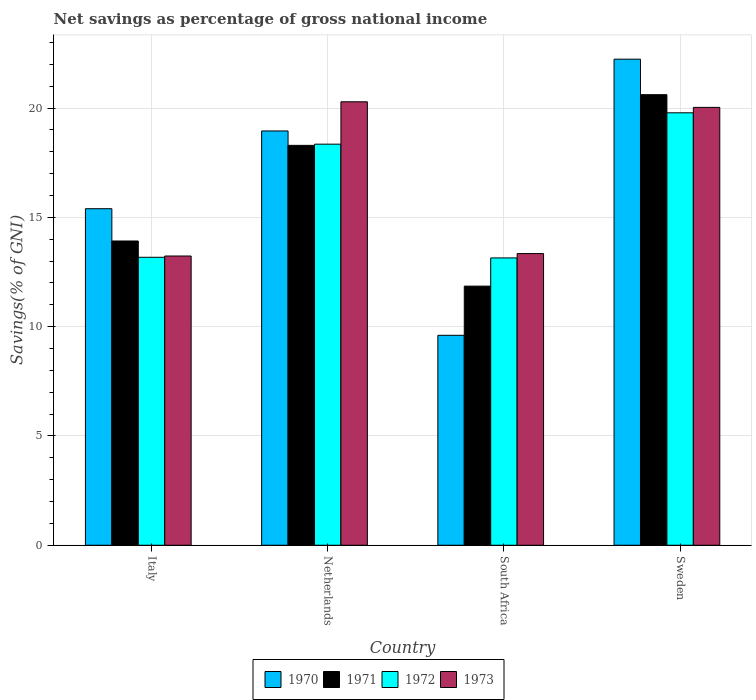How many different coloured bars are there?
Offer a very short reply. 4. How many groups of bars are there?
Your answer should be compact. 4. Are the number of bars on each tick of the X-axis equal?
Make the answer very short. Yes. How many bars are there on the 2nd tick from the left?
Offer a terse response. 4. How many bars are there on the 1st tick from the right?
Your answer should be very brief. 4. What is the label of the 4th group of bars from the left?
Your answer should be very brief. Sweden. What is the total savings in 1973 in South Africa?
Keep it short and to the point. 13.34. Across all countries, what is the maximum total savings in 1970?
Ensure brevity in your answer.  22.24. Across all countries, what is the minimum total savings in 1970?
Your response must be concise. 9.6. In which country was the total savings in 1972 minimum?
Your answer should be compact. South Africa. What is the total total savings in 1970 in the graph?
Keep it short and to the point. 66.19. What is the difference between the total savings in 1971 in Netherlands and that in Sweden?
Ensure brevity in your answer.  -2.32. What is the difference between the total savings in 1972 in South Africa and the total savings in 1973 in Sweden?
Provide a succinct answer. -6.89. What is the average total savings in 1971 per country?
Provide a short and direct response. 16.17. What is the difference between the total savings of/in 1970 and total savings of/in 1971 in South Africa?
Your response must be concise. -2.25. What is the ratio of the total savings in 1971 in Italy to that in Sweden?
Your response must be concise. 0.68. What is the difference between the highest and the second highest total savings in 1973?
Your answer should be very brief. -6.95. What is the difference between the highest and the lowest total savings in 1971?
Make the answer very short. 8.76. Is it the case that in every country, the sum of the total savings in 1972 and total savings in 1970 is greater than the sum of total savings in 1971 and total savings in 1973?
Your answer should be very brief. No. What does the 4th bar from the left in Italy represents?
Give a very brief answer. 1973. What is the difference between two consecutive major ticks on the Y-axis?
Your answer should be compact. 5. How many legend labels are there?
Your response must be concise. 4. How are the legend labels stacked?
Keep it short and to the point. Horizontal. What is the title of the graph?
Ensure brevity in your answer.  Net savings as percentage of gross national income. Does "2006" appear as one of the legend labels in the graph?
Your response must be concise. No. What is the label or title of the X-axis?
Provide a succinct answer. Country. What is the label or title of the Y-axis?
Your answer should be compact. Savings(% of GNI). What is the Savings(% of GNI) in 1970 in Italy?
Your response must be concise. 15.4. What is the Savings(% of GNI) in 1971 in Italy?
Keep it short and to the point. 13.92. What is the Savings(% of GNI) in 1972 in Italy?
Ensure brevity in your answer.  13.17. What is the Savings(% of GNI) of 1973 in Italy?
Provide a short and direct response. 13.23. What is the Savings(% of GNI) of 1970 in Netherlands?
Make the answer very short. 18.95. What is the Savings(% of GNI) in 1971 in Netherlands?
Your answer should be compact. 18.29. What is the Savings(% of GNI) in 1972 in Netherlands?
Offer a very short reply. 18.35. What is the Savings(% of GNI) of 1973 in Netherlands?
Offer a very short reply. 20.29. What is the Savings(% of GNI) of 1970 in South Africa?
Your answer should be compact. 9.6. What is the Savings(% of GNI) of 1971 in South Africa?
Keep it short and to the point. 11.85. What is the Savings(% of GNI) of 1972 in South Africa?
Your response must be concise. 13.14. What is the Savings(% of GNI) in 1973 in South Africa?
Provide a succinct answer. 13.34. What is the Savings(% of GNI) in 1970 in Sweden?
Your response must be concise. 22.24. What is the Savings(% of GNI) of 1971 in Sweden?
Keep it short and to the point. 20.61. What is the Savings(% of GNI) of 1972 in Sweden?
Provide a short and direct response. 19.78. What is the Savings(% of GNI) of 1973 in Sweden?
Make the answer very short. 20.03. Across all countries, what is the maximum Savings(% of GNI) in 1970?
Make the answer very short. 22.24. Across all countries, what is the maximum Savings(% of GNI) in 1971?
Provide a succinct answer. 20.61. Across all countries, what is the maximum Savings(% of GNI) of 1972?
Your answer should be very brief. 19.78. Across all countries, what is the maximum Savings(% of GNI) of 1973?
Your answer should be compact. 20.29. Across all countries, what is the minimum Savings(% of GNI) in 1970?
Give a very brief answer. 9.6. Across all countries, what is the minimum Savings(% of GNI) of 1971?
Make the answer very short. 11.85. Across all countries, what is the minimum Savings(% of GNI) in 1972?
Ensure brevity in your answer.  13.14. Across all countries, what is the minimum Savings(% of GNI) in 1973?
Keep it short and to the point. 13.23. What is the total Savings(% of GNI) of 1970 in the graph?
Provide a short and direct response. 66.19. What is the total Savings(% of GNI) of 1971 in the graph?
Ensure brevity in your answer.  64.68. What is the total Savings(% of GNI) in 1972 in the graph?
Offer a very short reply. 64.45. What is the total Savings(% of GNI) of 1973 in the graph?
Provide a short and direct response. 66.89. What is the difference between the Savings(% of GNI) of 1970 in Italy and that in Netherlands?
Make the answer very short. -3.56. What is the difference between the Savings(% of GNI) of 1971 in Italy and that in Netherlands?
Provide a short and direct response. -4.37. What is the difference between the Savings(% of GNI) in 1972 in Italy and that in Netherlands?
Provide a succinct answer. -5.18. What is the difference between the Savings(% of GNI) in 1973 in Italy and that in Netherlands?
Your answer should be very brief. -7.06. What is the difference between the Savings(% of GNI) in 1970 in Italy and that in South Africa?
Your answer should be very brief. 5.79. What is the difference between the Savings(% of GNI) in 1971 in Italy and that in South Africa?
Your answer should be compact. 2.07. What is the difference between the Savings(% of GNI) of 1972 in Italy and that in South Africa?
Offer a very short reply. 0.03. What is the difference between the Savings(% of GNI) of 1973 in Italy and that in South Africa?
Your answer should be compact. -0.11. What is the difference between the Savings(% of GNI) of 1970 in Italy and that in Sweden?
Your answer should be very brief. -6.84. What is the difference between the Savings(% of GNI) of 1971 in Italy and that in Sweden?
Keep it short and to the point. -6.69. What is the difference between the Savings(% of GNI) in 1972 in Italy and that in Sweden?
Provide a short and direct response. -6.61. What is the difference between the Savings(% of GNI) of 1973 in Italy and that in Sweden?
Make the answer very short. -6.8. What is the difference between the Savings(% of GNI) in 1970 in Netherlands and that in South Africa?
Provide a short and direct response. 9.35. What is the difference between the Savings(% of GNI) of 1971 in Netherlands and that in South Africa?
Make the answer very short. 6.44. What is the difference between the Savings(% of GNI) of 1972 in Netherlands and that in South Africa?
Give a very brief answer. 5.21. What is the difference between the Savings(% of GNI) in 1973 in Netherlands and that in South Africa?
Your answer should be very brief. 6.95. What is the difference between the Savings(% of GNI) of 1970 in Netherlands and that in Sweden?
Ensure brevity in your answer.  -3.28. What is the difference between the Savings(% of GNI) of 1971 in Netherlands and that in Sweden?
Your response must be concise. -2.32. What is the difference between the Savings(% of GNI) of 1972 in Netherlands and that in Sweden?
Offer a very short reply. -1.43. What is the difference between the Savings(% of GNI) of 1973 in Netherlands and that in Sweden?
Make the answer very short. 0.26. What is the difference between the Savings(% of GNI) of 1970 in South Africa and that in Sweden?
Provide a short and direct response. -12.63. What is the difference between the Savings(% of GNI) in 1971 in South Africa and that in Sweden?
Your answer should be very brief. -8.76. What is the difference between the Savings(% of GNI) in 1972 in South Africa and that in Sweden?
Provide a short and direct response. -6.64. What is the difference between the Savings(% of GNI) in 1973 in South Africa and that in Sweden?
Offer a terse response. -6.69. What is the difference between the Savings(% of GNI) of 1970 in Italy and the Savings(% of GNI) of 1971 in Netherlands?
Keep it short and to the point. -2.9. What is the difference between the Savings(% of GNI) of 1970 in Italy and the Savings(% of GNI) of 1972 in Netherlands?
Offer a terse response. -2.95. What is the difference between the Savings(% of GNI) of 1970 in Italy and the Savings(% of GNI) of 1973 in Netherlands?
Give a very brief answer. -4.89. What is the difference between the Savings(% of GNI) in 1971 in Italy and the Savings(% of GNI) in 1972 in Netherlands?
Your response must be concise. -4.43. What is the difference between the Savings(% of GNI) in 1971 in Italy and the Savings(% of GNI) in 1973 in Netherlands?
Ensure brevity in your answer.  -6.37. What is the difference between the Savings(% of GNI) of 1972 in Italy and the Savings(% of GNI) of 1973 in Netherlands?
Offer a very short reply. -7.11. What is the difference between the Savings(% of GNI) in 1970 in Italy and the Savings(% of GNI) in 1971 in South Africa?
Ensure brevity in your answer.  3.54. What is the difference between the Savings(% of GNI) in 1970 in Italy and the Savings(% of GNI) in 1972 in South Africa?
Provide a short and direct response. 2.25. What is the difference between the Savings(% of GNI) in 1970 in Italy and the Savings(% of GNI) in 1973 in South Africa?
Offer a terse response. 2.05. What is the difference between the Savings(% of GNI) in 1971 in Italy and the Savings(% of GNI) in 1972 in South Africa?
Ensure brevity in your answer.  0.78. What is the difference between the Savings(% of GNI) of 1971 in Italy and the Savings(% of GNI) of 1973 in South Africa?
Keep it short and to the point. 0.58. What is the difference between the Savings(% of GNI) of 1972 in Italy and the Savings(% of GNI) of 1973 in South Africa?
Offer a very short reply. -0.17. What is the difference between the Savings(% of GNI) of 1970 in Italy and the Savings(% of GNI) of 1971 in Sweden?
Your answer should be very brief. -5.22. What is the difference between the Savings(% of GNI) in 1970 in Italy and the Savings(% of GNI) in 1972 in Sweden?
Your response must be concise. -4.39. What is the difference between the Savings(% of GNI) in 1970 in Italy and the Savings(% of GNI) in 1973 in Sweden?
Give a very brief answer. -4.64. What is the difference between the Savings(% of GNI) in 1971 in Italy and the Savings(% of GNI) in 1972 in Sweden?
Offer a very short reply. -5.86. What is the difference between the Savings(% of GNI) in 1971 in Italy and the Savings(% of GNI) in 1973 in Sweden?
Keep it short and to the point. -6.11. What is the difference between the Savings(% of GNI) of 1972 in Italy and the Savings(% of GNI) of 1973 in Sweden?
Give a very brief answer. -6.86. What is the difference between the Savings(% of GNI) of 1970 in Netherlands and the Savings(% of GNI) of 1971 in South Africa?
Give a very brief answer. 7.1. What is the difference between the Savings(% of GNI) in 1970 in Netherlands and the Savings(% of GNI) in 1972 in South Africa?
Offer a terse response. 5.81. What is the difference between the Savings(% of GNI) in 1970 in Netherlands and the Savings(% of GNI) in 1973 in South Africa?
Keep it short and to the point. 5.61. What is the difference between the Savings(% of GNI) of 1971 in Netherlands and the Savings(% of GNI) of 1972 in South Africa?
Provide a short and direct response. 5.15. What is the difference between the Savings(% of GNI) of 1971 in Netherlands and the Savings(% of GNI) of 1973 in South Africa?
Give a very brief answer. 4.95. What is the difference between the Savings(% of GNI) of 1972 in Netherlands and the Savings(% of GNI) of 1973 in South Africa?
Offer a terse response. 5.01. What is the difference between the Savings(% of GNI) in 1970 in Netherlands and the Savings(% of GNI) in 1971 in Sweden?
Offer a terse response. -1.66. What is the difference between the Savings(% of GNI) of 1970 in Netherlands and the Savings(% of GNI) of 1972 in Sweden?
Offer a terse response. -0.83. What is the difference between the Savings(% of GNI) in 1970 in Netherlands and the Savings(% of GNI) in 1973 in Sweden?
Your response must be concise. -1.08. What is the difference between the Savings(% of GNI) in 1971 in Netherlands and the Savings(% of GNI) in 1972 in Sweden?
Give a very brief answer. -1.49. What is the difference between the Savings(% of GNI) of 1971 in Netherlands and the Savings(% of GNI) of 1973 in Sweden?
Offer a terse response. -1.74. What is the difference between the Savings(% of GNI) in 1972 in Netherlands and the Savings(% of GNI) in 1973 in Sweden?
Offer a very short reply. -1.68. What is the difference between the Savings(% of GNI) of 1970 in South Africa and the Savings(% of GNI) of 1971 in Sweden?
Provide a short and direct response. -11.01. What is the difference between the Savings(% of GNI) in 1970 in South Africa and the Savings(% of GNI) in 1972 in Sweden?
Your answer should be compact. -10.18. What is the difference between the Savings(% of GNI) in 1970 in South Africa and the Savings(% of GNI) in 1973 in Sweden?
Ensure brevity in your answer.  -10.43. What is the difference between the Savings(% of GNI) in 1971 in South Africa and the Savings(% of GNI) in 1972 in Sweden?
Your answer should be compact. -7.93. What is the difference between the Savings(% of GNI) in 1971 in South Africa and the Savings(% of GNI) in 1973 in Sweden?
Provide a short and direct response. -8.18. What is the difference between the Savings(% of GNI) in 1972 in South Africa and the Savings(% of GNI) in 1973 in Sweden?
Offer a very short reply. -6.89. What is the average Savings(% of GNI) of 1970 per country?
Provide a short and direct response. 16.55. What is the average Savings(% of GNI) in 1971 per country?
Your response must be concise. 16.17. What is the average Savings(% of GNI) in 1972 per country?
Your answer should be very brief. 16.11. What is the average Savings(% of GNI) of 1973 per country?
Provide a succinct answer. 16.72. What is the difference between the Savings(% of GNI) in 1970 and Savings(% of GNI) in 1971 in Italy?
Ensure brevity in your answer.  1.48. What is the difference between the Savings(% of GNI) of 1970 and Savings(% of GNI) of 1972 in Italy?
Your response must be concise. 2.22. What is the difference between the Savings(% of GNI) in 1970 and Savings(% of GNI) in 1973 in Italy?
Offer a terse response. 2.16. What is the difference between the Savings(% of GNI) of 1971 and Savings(% of GNI) of 1972 in Italy?
Provide a succinct answer. 0.75. What is the difference between the Savings(% of GNI) of 1971 and Savings(% of GNI) of 1973 in Italy?
Offer a very short reply. 0.69. What is the difference between the Savings(% of GNI) in 1972 and Savings(% of GNI) in 1973 in Italy?
Give a very brief answer. -0.06. What is the difference between the Savings(% of GNI) of 1970 and Savings(% of GNI) of 1971 in Netherlands?
Provide a short and direct response. 0.66. What is the difference between the Savings(% of GNI) of 1970 and Savings(% of GNI) of 1972 in Netherlands?
Offer a very short reply. 0.6. What is the difference between the Savings(% of GNI) of 1970 and Savings(% of GNI) of 1973 in Netherlands?
Provide a short and direct response. -1.33. What is the difference between the Savings(% of GNI) of 1971 and Savings(% of GNI) of 1972 in Netherlands?
Offer a very short reply. -0.06. What is the difference between the Savings(% of GNI) of 1971 and Savings(% of GNI) of 1973 in Netherlands?
Provide a succinct answer. -1.99. What is the difference between the Savings(% of GNI) of 1972 and Savings(% of GNI) of 1973 in Netherlands?
Ensure brevity in your answer.  -1.94. What is the difference between the Savings(% of GNI) in 1970 and Savings(% of GNI) in 1971 in South Africa?
Provide a succinct answer. -2.25. What is the difference between the Savings(% of GNI) of 1970 and Savings(% of GNI) of 1972 in South Africa?
Offer a very short reply. -3.54. What is the difference between the Savings(% of GNI) of 1970 and Savings(% of GNI) of 1973 in South Africa?
Your response must be concise. -3.74. What is the difference between the Savings(% of GNI) of 1971 and Savings(% of GNI) of 1972 in South Africa?
Offer a very short reply. -1.29. What is the difference between the Savings(% of GNI) in 1971 and Savings(% of GNI) in 1973 in South Africa?
Your answer should be compact. -1.49. What is the difference between the Savings(% of GNI) in 1972 and Savings(% of GNI) in 1973 in South Africa?
Make the answer very short. -0.2. What is the difference between the Savings(% of GNI) of 1970 and Savings(% of GNI) of 1971 in Sweden?
Offer a very short reply. 1.62. What is the difference between the Savings(% of GNI) in 1970 and Savings(% of GNI) in 1972 in Sweden?
Keep it short and to the point. 2.45. What is the difference between the Savings(% of GNI) of 1970 and Savings(% of GNI) of 1973 in Sweden?
Ensure brevity in your answer.  2.21. What is the difference between the Savings(% of GNI) in 1971 and Savings(% of GNI) in 1972 in Sweden?
Provide a succinct answer. 0.83. What is the difference between the Savings(% of GNI) of 1971 and Savings(% of GNI) of 1973 in Sweden?
Provide a succinct answer. 0.58. What is the difference between the Savings(% of GNI) in 1972 and Savings(% of GNI) in 1973 in Sweden?
Provide a succinct answer. -0.25. What is the ratio of the Savings(% of GNI) of 1970 in Italy to that in Netherlands?
Provide a short and direct response. 0.81. What is the ratio of the Savings(% of GNI) in 1971 in Italy to that in Netherlands?
Give a very brief answer. 0.76. What is the ratio of the Savings(% of GNI) in 1972 in Italy to that in Netherlands?
Make the answer very short. 0.72. What is the ratio of the Savings(% of GNI) of 1973 in Italy to that in Netherlands?
Your answer should be very brief. 0.65. What is the ratio of the Savings(% of GNI) of 1970 in Italy to that in South Africa?
Your answer should be very brief. 1.6. What is the ratio of the Savings(% of GNI) of 1971 in Italy to that in South Africa?
Ensure brevity in your answer.  1.17. What is the ratio of the Savings(% of GNI) in 1973 in Italy to that in South Africa?
Ensure brevity in your answer.  0.99. What is the ratio of the Savings(% of GNI) in 1970 in Italy to that in Sweden?
Offer a very short reply. 0.69. What is the ratio of the Savings(% of GNI) of 1971 in Italy to that in Sweden?
Offer a terse response. 0.68. What is the ratio of the Savings(% of GNI) in 1972 in Italy to that in Sweden?
Your response must be concise. 0.67. What is the ratio of the Savings(% of GNI) in 1973 in Italy to that in Sweden?
Your answer should be very brief. 0.66. What is the ratio of the Savings(% of GNI) of 1970 in Netherlands to that in South Africa?
Provide a short and direct response. 1.97. What is the ratio of the Savings(% of GNI) in 1971 in Netherlands to that in South Africa?
Your answer should be very brief. 1.54. What is the ratio of the Savings(% of GNI) of 1972 in Netherlands to that in South Africa?
Ensure brevity in your answer.  1.4. What is the ratio of the Savings(% of GNI) of 1973 in Netherlands to that in South Africa?
Give a very brief answer. 1.52. What is the ratio of the Savings(% of GNI) of 1970 in Netherlands to that in Sweden?
Make the answer very short. 0.85. What is the ratio of the Savings(% of GNI) of 1971 in Netherlands to that in Sweden?
Make the answer very short. 0.89. What is the ratio of the Savings(% of GNI) in 1972 in Netherlands to that in Sweden?
Offer a very short reply. 0.93. What is the ratio of the Savings(% of GNI) in 1973 in Netherlands to that in Sweden?
Offer a very short reply. 1.01. What is the ratio of the Savings(% of GNI) of 1970 in South Africa to that in Sweden?
Provide a short and direct response. 0.43. What is the ratio of the Savings(% of GNI) in 1971 in South Africa to that in Sweden?
Your answer should be very brief. 0.58. What is the ratio of the Savings(% of GNI) in 1972 in South Africa to that in Sweden?
Offer a very short reply. 0.66. What is the ratio of the Savings(% of GNI) of 1973 in South Africa to that in Sweden?
Give a very brief answer. 0.67. What is the difference between the highest and the second highest Savings(% of GNI) of 1970?
Offer a terse response. 3.28. What is the difference between the highest and the second highest Savings(% of GNI) in 1971?
Offer a terse response. 2.32. What is the difference between the highest and the second highest Savings(% of GNI) in 1972?
Provide a short and direct response. 1.43. What is the difference between the highest and the second highest Savings(% of GNI) of 1973?
Provide a short and direct response. 0.26. What is the difference between the highest and the lowest Savings(% of GNI) of 1970?
Offer a terse response. 12.63. What is the difference between the highest and the lowest Savings(% of GNI) in 1971?
Keep it short and to the point. 8.76. What is the difference between the highest and the lowest Savings(% of GNI) of 1972?
Your response must be concise. 6.64. What is the difference between the highest and the lowest Savings(% of GNI) of 1973?
Your answer should be compact. 7.06. 